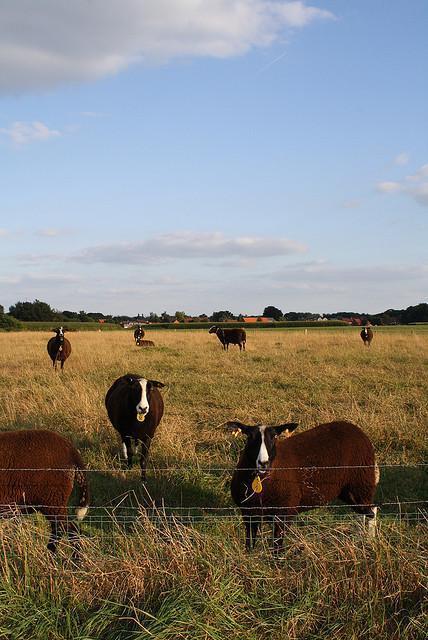How many sheep are in the photo?
Give a very brief answer. 3. 